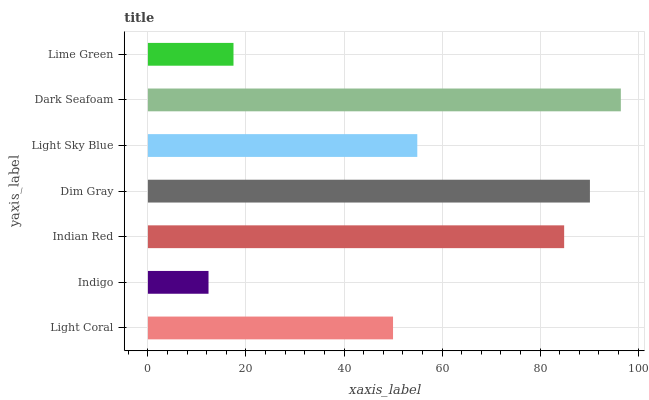Is Indigo the minimum?
Answer yes or no. Yes. Is Dark Seafoam the maximum?
Answer yes or no. Yes. Is Indian Red the minimum?
Answer yes or no. No. Is Indian Red the maximum?
Answer yes or no. No. Is Indian Red greater than Indigo?
Answer yes or no. Yes. Is Indigo less than Indian Red?
Answer yes or no. Yes. Is Indigo greater than Indian Red?
Answer yes or no. No. Is Indian Red less than Indigo?
Answer yes or no. No. Is Light Sky Blue the high median?
Answer yes or no. Yes. Is Light Sky Blue the low median?
Answer yes or no. Yes. Is Indian Red the high median?
Answer yes or no. No. Is Dim Gray the low median?
Answer yes or no. No. 